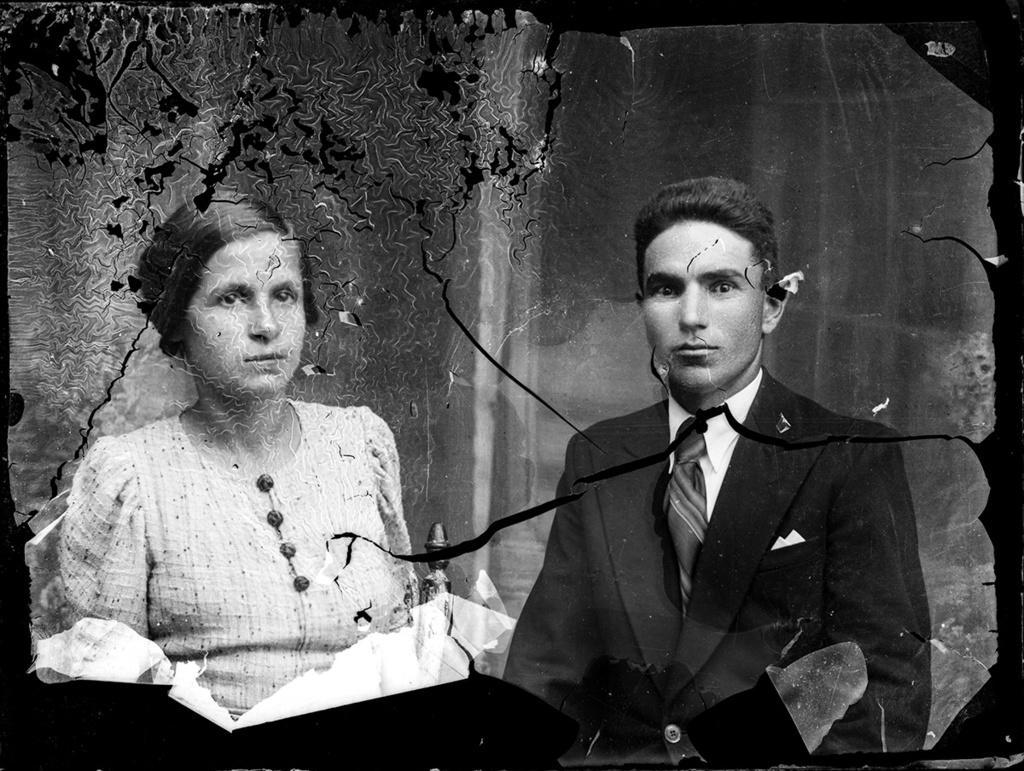Can you describe this image briefly? In the image we can see there is a paper and there are people standing. The image is in black and white colour. 